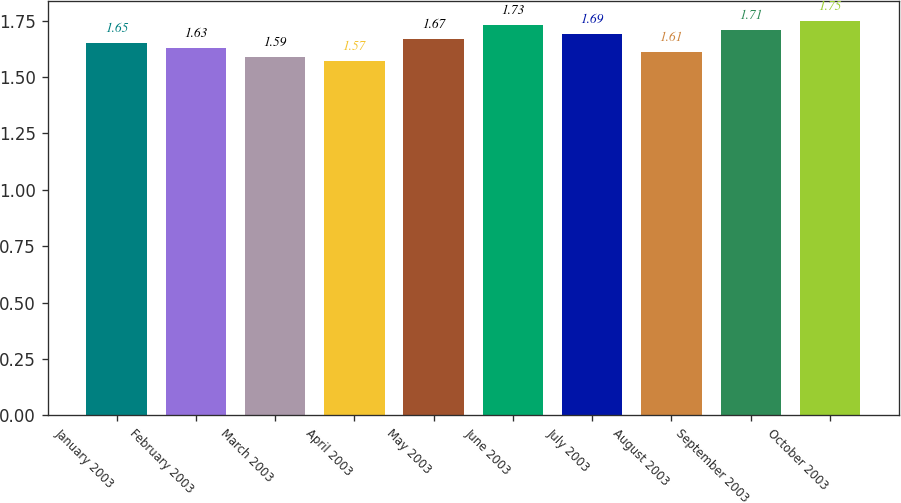<chart> <loc_0><loc_0><loc_500><loc_500><bar_chart><fcel>January 2003<fcel>February 2003<fcel>March 2003<fcel>April 2003<fcel>May 2003<fcel>June 2003<fcel>July 2003<fcel>August 2003<fcel>September 2003<fcel>October 2003<nl><fcel>1.65<fcel>1.63<fcel>1.59<fcel>1.57<fcel>1.67<fcel>1.73<fcel>1.69<fcel>1.61<fcel>1.71<fcel>1.75<nl></chart> 